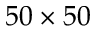Convert formula to latex. <formula><loc_0><loc_0><loc_500><loc_500>5 0 \times 5 0</formula> 